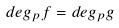Convert formula to latex. <formula><loc_0><loc_0><loc_500><loc_500>d e g _ { p } f = d e g _ { p } g</formula> 